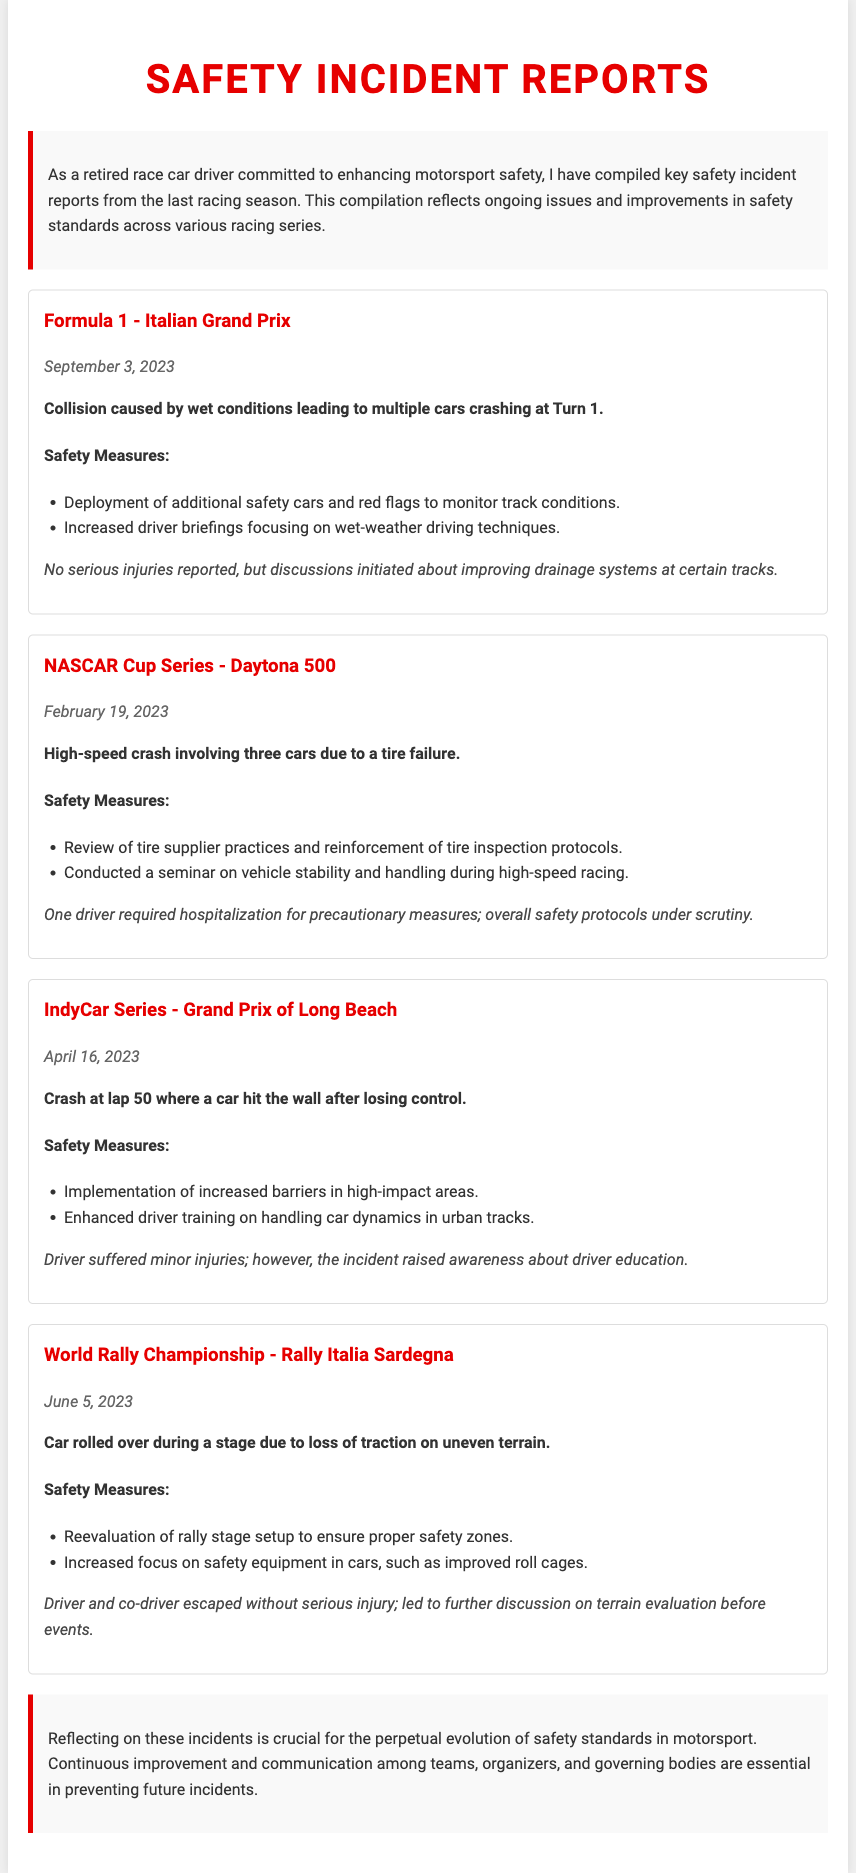what is the title of the document? The title of the document is displayed prominently as a header at the top of the content.
Answer: Safety Incident Reports which racing event had an incident on September 3, 2023? The incident on September 3, 2023, is linked to a specific racing event mentioned in one of the reports in the document.
Answer: Formula 1 - Italian Grand Prix what was the outcome of the Daytona 500 incident? The outcome describes the implications of the incident, specifically mentioning the hospitalization of one driver.
Answer: One driver required hospitalization for precautionary measures how many cars were involved in the crash at the Grand Prix of Long Beach? The number of cars involved is explicitly mentioned in the incident description for that particular event in the document.
Answer: One car what safety measure was implemented after the World Rally Championship incident? A specific safety measure implemented is noted in the section detailing the incident responses meant to enhance safety.
Answer: Reevaluation of rally stage setup what common factor can be deduced from the incidents outlined in the document? The document suggests a shared understanding or common focus that arose from all incidents, highlighting the need for improvement.
Answer: Continuous improvement in safety standards 